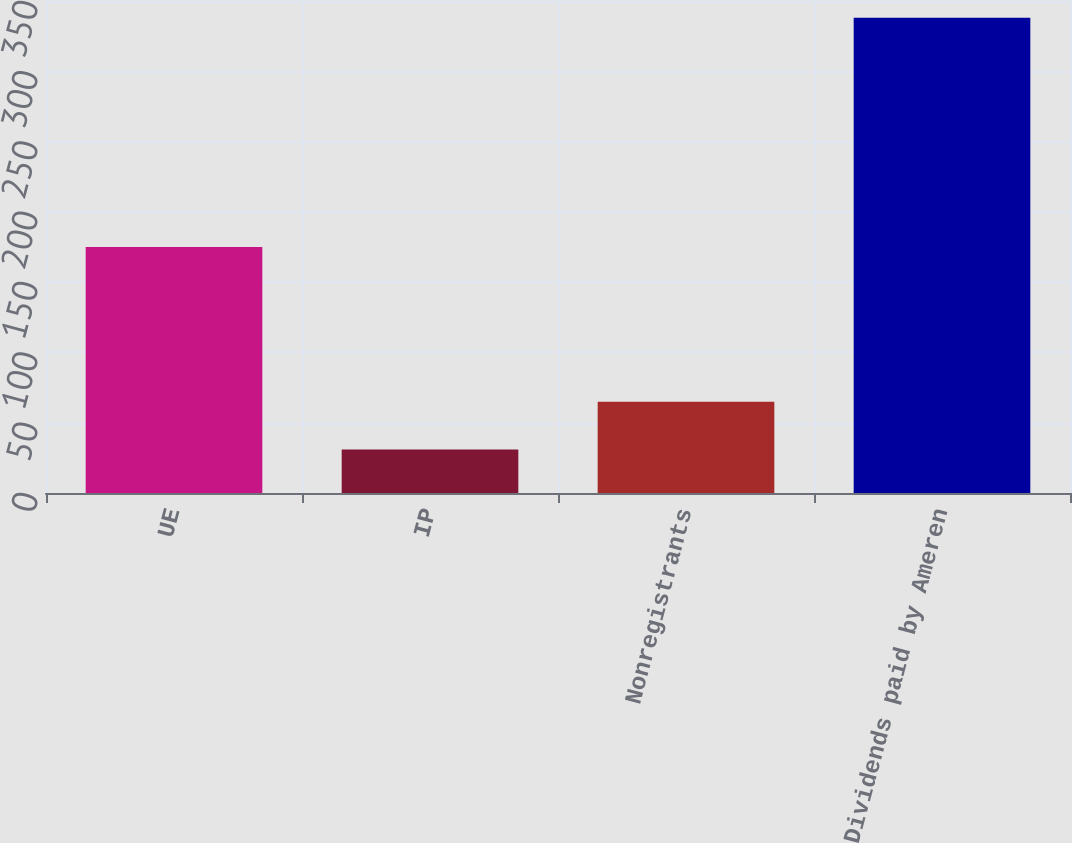<chart> <loc_0><loc_0><loc_500><loc_500><bar_chart><fcel>UE<fcel>IP<fcel>Nonregistrants<fcel>Dividends paid by Ameren<nl><fcel>175<fcel>31<fcel>65<fcel>338<nl></chart> 